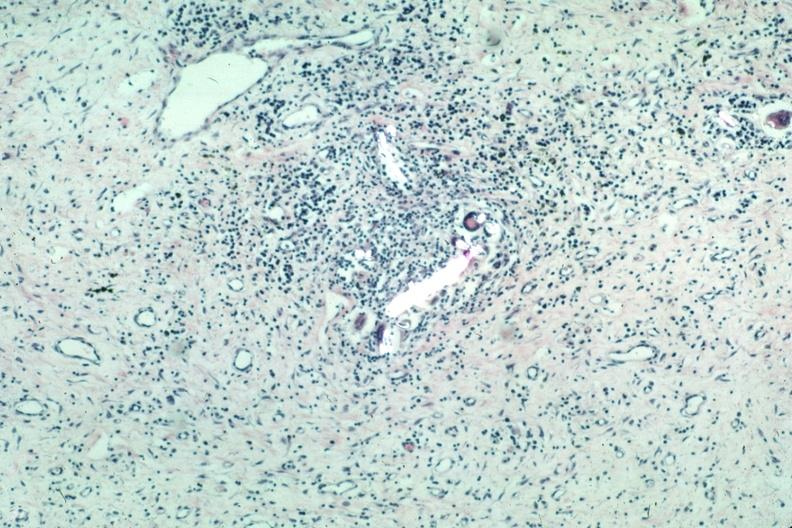what does this image show?
Answer the question using a single word or phrase. With partially crossed polarizing to show foreign material very typical 